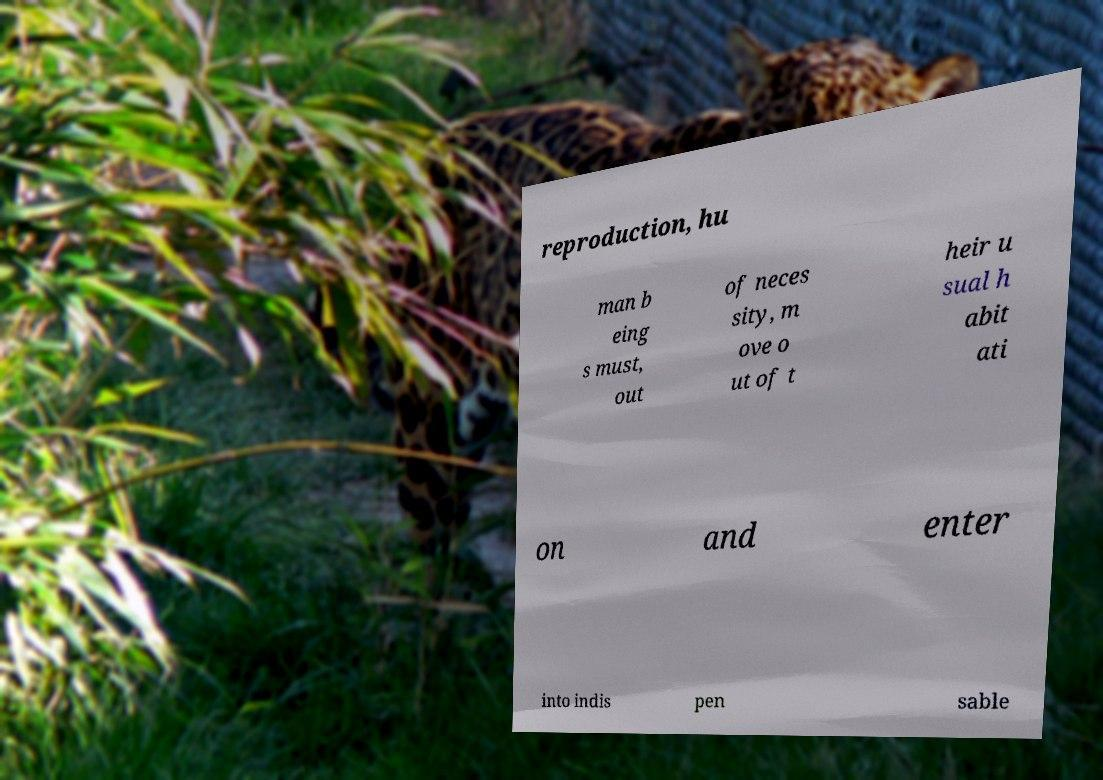For documentation purposes, I need the text within this image transcribed. Could you provide that? reproduction, hu man b eing s must, out of neces sity, m ove o ut of t heir u sual h abit ati on and enter into indis pen sable 